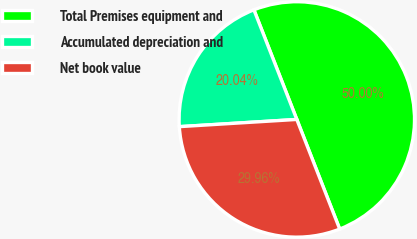<chart> <loc_0><loc_0><loc_500><loc_500><pie_chart><fcel>Total Premises equipment and<fcel>Accumulated depreciation and<fcel>Net book value<nl><fcel>50.0%<fcel>20.04%<fcel>29.96%<nl></chart> 